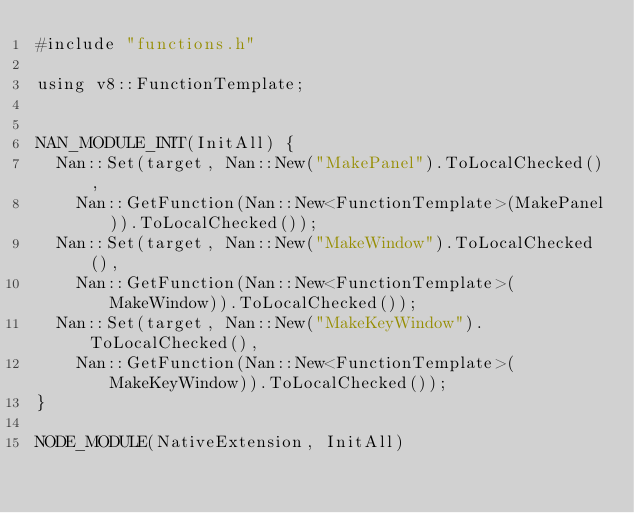Convert code to text. <code><loc_0><loc_0><loc_500><loc_500><_ObjectiveC_>#include "functions.h"

using v8::FunctionTemplate;


NAN_MODULE_INIT(InitAll) {
  Nan::Set(target, Nan::New("MakePanel").ToLocalChecked(),
    Nan::GetFunction(Nan::New<FunctionTemplate>(MakePanel)).ToLocalChecked());
  Nan::Set(target, Nan::New("MakeWindow").ToLocalChecked(),
    Nan::GetFunction(Nan::New<FunctionTemplate>(MakeWindow)).ToLocalChecked());
  Nan::Set(target, Nan::New("MakeKeyWindow").ToLocalChecked(),
    Nan::GetFunction(Nan::New<FunctionTemplate>(MakeKeyWindow)).ToLocalChecked());
}

NODE_MODULE(NativeExtension, InitAll)
</code> 